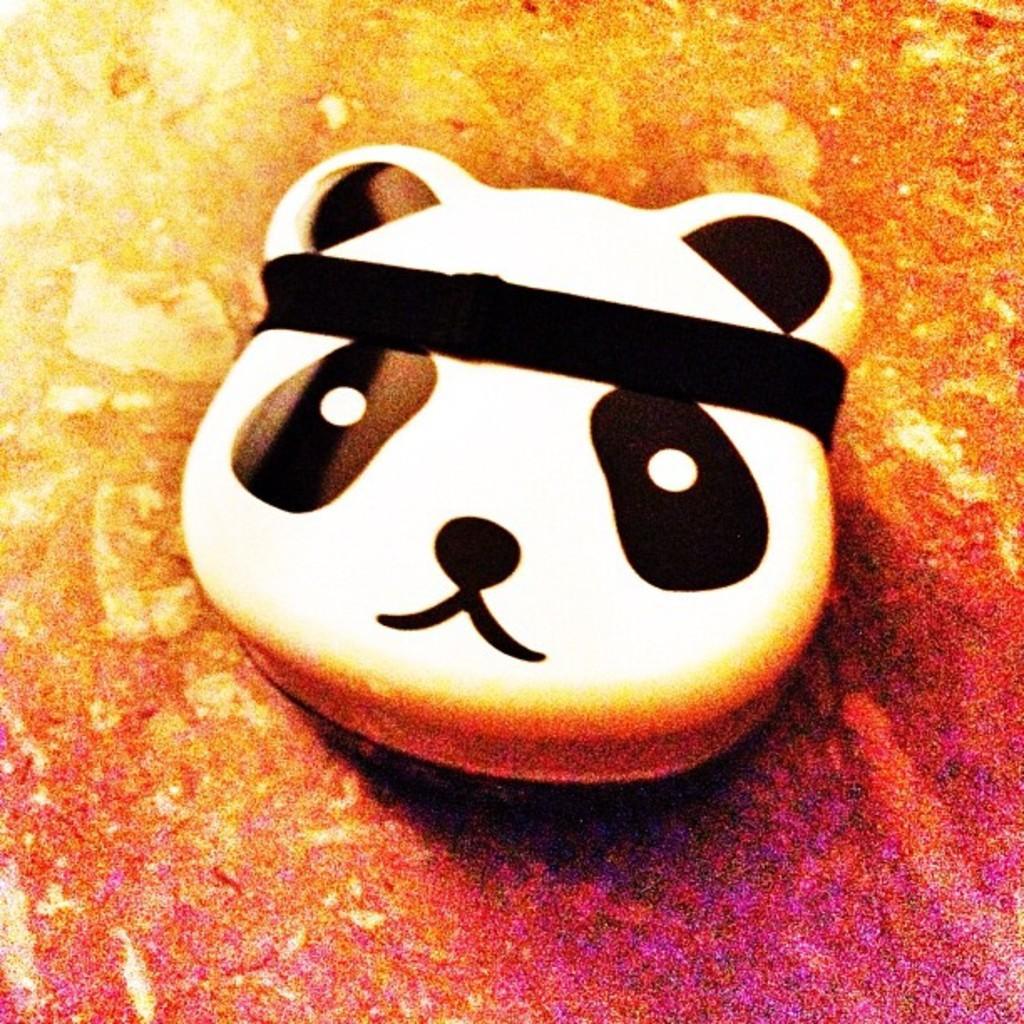Describe this image in one or two sentences. In the picture I can see the face of a panda toy which is placed on the surface. 